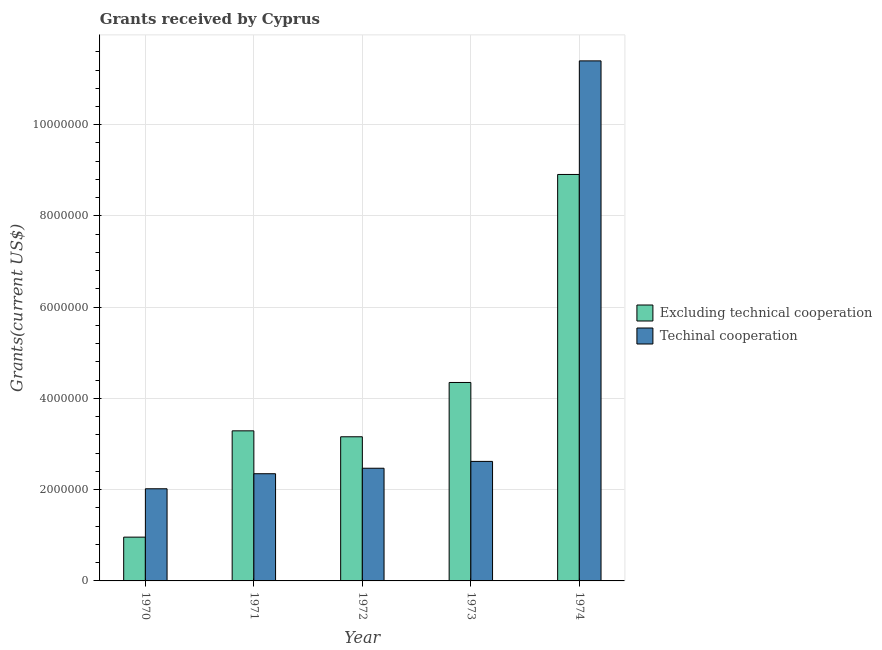How many groups of bars are there?
Your response must be concise. 5. Are the number of bars per tick equal to the number of legend labels?
Your answer should be compact. Yes. How many bars are there on the 2nd tick from the right?
Make the answer very short. 2. What is the amount of grants received(excluding technical cooperation) in 1971?
Give a very brief answer. 3.29e+06. Across all years, what is the maximum amount of grants received(excluding technical cooperation)?
Make the answer very short. 8.91e+06. Across all years, what is the minimum amount of grants received(including technical cooperation)?
Give a very brief answer. 2.02e+06. In which year was the amount of grants received(including technical cooperation) maximum?
Your response must be concise. 1974. What is the total amount of grants received(excluding technical cooperation) in the graph?
Provide a succinct answer. 2.07e+07. What is the difference between the amount of grants received(including technical cooperation) in 1971 and that in 1972?
Your answer should be very brief. -1.20e+05. What is the difference between the amount of grants received(including technical cooperation) in 1973 and the amount of grants received(excluding technical cooperation) in 1970?
Your answer should be compact. 6.00e+05. What is the average amount of grants received(including technical cooperation) per year?
Keep it short and to the point. 4.17e+06. What is the ratio of the amount of grants received(excluding technical cooperation) in 1973 to that in 1974?
Provide a succinct answer. 0.49. Is the amount of grants received(including technical cooperation) in 1970 less than that in 1973?
Provide a short and direct response. Yes. Is the difference between the amount of grants received(including technical cooperation) in 1970 and 1974 greater than the difference between the amount of grants received(excluding technical cooperation) in 1970 and 1974?
Provide a short and direct response. No. What is the difference between the highest and the second highest amount of grants received(including technical cooperation)?
Offer a terse response. 8.78e+06. What is the difference between the highest and the lowest amount of grants received(excluding technical cooperation)?
Keep it short and to the point. 7.95e+06. Is the sum of the amount of grants received(including technical cooperation) in 1972 and 1973 greater than the maximum amount of grants received(excluding technical cooperation) across all years?
Your answer should be very brief. No. What does the 1st bar from the left in 1973 represents?
Give a very brief answer. Excluding technical cooperation. What does the 2nd bar from the right in 1971 represents?
Your answer should be compact. Excluding technical cooperation. How many bars are there?
Provide a succinct answer. 10. How many years are there in the graph?
Make the answer very short. 5. What is the difference between two consecutive major ticks on the Y-axis?
Keep it short and to the point. 2.00e+06. Are the values on the major ticks of Y-axis written in scientific E-notation?
Give a very brief answer. No. Does the graph contain any zero values?
Make the answer very short. No. Does the graph contain grids?
Ensure brevity in your answer.  Yes. Where does the legend appear in the graph?
Keep it short and to the point. Center right. What is the title of the graph?
Offer a very short reply. Grants received by Cyprus. Does "Domestic Liabilities" appear as one of the legend labels in the graph?
Give a very brief answer. No. What is the label or title of the Y-axis?
Provide a succinct answer. Grants(current US$). What is the Grants(current US$) of Excluding technical cooperation in 1970?
Your answer should be compact. 9.60e+05. What is the Grants(current US$) in Techinal cooperation in 1970?
Provide a succinct answer. 2.02e+06. What is the Grants(current US$) of Excluding technical cooperation in 1971?
Offer a terse response. 3.29e+06. What is the Grants(current US$) in Techinal cooperation in 1971?
Your answer should be very brief. 2.35e+06. What is the Grants(current US$) of Excluding technical cooperation in 1972?
Provide a short and direct response. 3.16e+06. What is the Grants(current US$) in Techinal cooperation in 1972?
Keep it short and to the point. 2.47e+06. What is the Grants(current US$) of Excluding technical cooperation in 1973?
Your answer should be compact. 4.35e+06. What is the Grants(current US$) in Techinal cooperation in 1973?
Provide a succinct answer. 2.62e+06. What is the Grants(current US$) in Excluding technical cooperation in 1974?
Provide a succinct answer. 8.91e+06. What is the Grants(current US$) of Techinal cooperation in 1974?
Give a very brief answer. 1.14e+07. Across all years, what is the maximum Grants(current US$) of Excluding technical cooperation?
Ensure brevity in your answer.  8.91e+06. Across all years, what is the maximum Grants(current US$) of Techinal cooperation?
Make the answer very short. 1.14e+07. Across all years, what is the minimum Grants(current US$) in Excluding technical cooperation?
Offer a terse response. 9.60e+05. Across all years, what is the minimum Grants(current US$) of Techinal cooperation?
Provide a succinct answer. 2.02e+06. What is the total Grants(current US$) of Excluding technical cooperation in the graph?
Offer a very short reply. 2.07e+07. What is the total Grants(current US$) in Techinal cooperation in the graph?
Keep it short and to the point. 2.09e+07. What is the difference between the Grants(current US$) in Excluding technical cooperation in 1970 and that in 1971?
Give a very brief answer. -2.33e+06. What is the difference between the Grants(current US$) in Techinal cooperation in 1970 and that in 1971?
Offer a very short reply. -3.30e+05. What is the difference between the Grants(current US$) of Excluding technical cooperation in 1970 and that in 1972?
Offer a terse response. -2.20e+06. What is the difference between the Grants(current US$) of Techinal cooperation in 1970 and that in 1972?
Give a very brief answer. -4.50e+05. What is the difference between the Grants(current US$) in Excluding technical cooperation in 1970 and that in 1973?
Your answer should be very brief. -3.39e+06. What is the difference between the Grants(current US$) of Techinal cooperation in 1970 and that in 1973?
Make the answer very short. -6.00e+05. What is the difference between the Grants(current US$) of Excluding technical cooperation in 1970 and that in 1974?
Make the answer very short. -7.95e+06. What is the difference between the Grants(current US$) in Techinal cooperation in 1970 and that in 1974?
Provide a succinct answer. -9.38e+06. What is the difference between the Grants(current US$) of Techinal cooperation in 1971 and that in 1972?
Your answer should be very brief. -1.20e+05. What is the difference between the Grants(current US$) in Excluding technical cooperation in 1971 and that in 1973?
Your response must be concise. -1.06e+06. What is the difference between the Grants(current US$) in Excluding technical cooperation in 1971 and that in 1974?
Offer a very short reply. -5.62e+06. What is the difference between the Grants(current US$) in Techinal cooperation in 1971 and that in 1974?
Give a very brief answer. -9.05e+06. What is the difference between the Grants(current US$) in Excluding technical cooperation in 1972 and that in 1973?
Ensure brevity in your answer.  -1.19e+06. What is the difference between the Grants(current US$) of Excluding technical cooperation in 1972 and that in 1974?
Give a very brief answer. -5.75e+06. What is the difference between the Grants(current US$) in Techinal cooperation in 1972 and that in 1974?
Your answer should be compact. -8.93e+06. What is the difference between the Grants(current US$) of Excluding technical cooperation in 1973 and that in 1974?
Make the answer very short. -4.56e+06. What is the difference between the Grants(current US$) in Techinal cooperation in 1973 and that in 1974?
Your answer should be compact. -8.78e+06. What is the difference between the Grants(current US$) of Excluding technical cooperation in 1970 and the Grants(current US$) of Techinal cooperation in 1971?
Make the answer very short. -1.39e+06. What is the difference between the Grants(current US$) of Excluding technical cooperation in 1970 and the Grants(current US$) of Techinal cooperation in 1972?
Keep it short and to the point. -1.51e+06. What is the difference between the Grants(current US$) in Excluding technical cooperation in 1970 and the Grants(current US$) in Techinal cooperation in 1973?
Ensure brevity in your answer.  -1.66e+06. What is the difference between the Grants(current US$) in Excluding technical cooperation in 1970 and the Grants(current US$) in Techinal cooperation in 1974?
Offer a very short reply. -1.04e+07. What is the difference between the Grants(current US$) of Excluding technical cooperation in 1971 and the Grants(current US$) of Techinal cooperation in 1972?
Your answer should be very brief. 8.20e+05. What is the difference between the Grants(current US$) in Excluding technical cooperation in 1971 and the Grants(current US$) in Techinal cooperation in 1973?
Your answer should be very brief. 6.70e+05. What is the difference between the Grants(current US$) in Excluding technical cooperation in 1971 and the Grants(current US$) in Techinal cooperation in 1974?
Make the answer very short. -8.11e+06. What is the difference between the Grants(current US$) in Excluding technical cooperation in 1972 and the Grants(current US$) in Techinal cooperation in 1973?
Provide a short and direct response. 5.40e+05. What is the difference between the Grants(current US$) in Excluding technical cooperation in 1972 and the Grants(current US$) in Techinal cooperation in 1974?
Keep it short and to the point. -8.24e+06. What is the difference between the Grants(current US$) of Excluding technical cooperation in 1973 and the Grants(current US$) of Techinal cooperation in 1974?
Provide a short and direct response. -7.05e+06. What is the average Grants(current US$) in Excluding technical cooperation per year?
Your answer should be compact. 4.13e+06. What is the average Grants(current US$) in Techinal cooperation per year?
Your response must be concise. 4.17e+06. In the year 1970, what is the difference between the Grants(current US$) of Excluding technical cooperation and Grants(current US$) of Techinal cooperation?
Offer a very short reply. -1.06e+06. In the year 1971, what is the difference between the Grants(current US$) in Excluding technical cooperation and Grants(current US$) in Techinal cooperation?
Offer a terse response. 9.40e+05. In the year 1972, what is the difference between the Grants(current US$) in Excluding technical cooperation and Grants(current US$) in Techinal cooperation?
Your response must be concise. 6.90e+05. In the year 1973, what is the difference between the Grants(current US$) in Excluding technical cooperation and Grants(current US$) in Techinal cooperation?
Your answer should be compact. 1.73e+06. In the year 1974, what is the difference between the Grants(current US$) in Excluding technical cooperation and Grants(current US$) in Techinal cooperation?
Your response must be concise. -2.49e+06. What is the ratio of the Grants(current US$) in Excluding technical cooperation in 1970 to that in 1971?
Provide a short and direct response. 0.29. What is the ratio of the Grants(current US$) of Techinal cooperation in 1970 to that in 1971?
Keep it short and to the point. 0.86. What is the ratio of the Grants(current US$) in Excluding technical cooperation in 1970 to that in 1972?
Provide a short and direct response. 0.3. What is the ratio of the Grants(current US$) in Techinal cooperation in 1970 to that in 1972?
Your response must be concise. 0.82. What is the ratio of the Grants(current US$) in Excluding technical cooperation in 1970 to that in 1973?
Your answer should be compact. 0.22. What is the ratio of the Grants(current US$) of Techinal cooperation in 1970 to that in 1973?
Your response must be concise. 0.77. What is the ratio of the Grants(current US$) of Excluding technical cooperation in 1970 to that in 1974?
Offer a very short reply. 0.11. What is the ratio of the Grants(current US$) in Techinal cooperation in 1970 to that in 1974?
Offer a very short reply. 0.18. What is the ratio of the Grants(current US$) of Excluding technical cooperation in 1971 to that in 1972?
Your response must be concise. 1.04. What is the ratio of the Grants(current US$) in Techinal cooperation in 1971 to that in 1972?
Your response must be concise. 0.95. What is the ratio of the Grants(current US$) in Excluding technical cooperation in 1971 to that in 1973?
Your answer should be compact. 0.76. What is the ratio of the Grants(current US$) in Techinal cooperation in 1971 to that in 1973?
Keep it short and to the point. 0.9. What is the ratio of the Grants(current US$) in Excluding technical cooperation in 1971 to that in 1974?
Give a very brief answer. 0.37. What is the ratio of the Grants(current US$) in Techinal cooperation in 1971 to that in 1974?
Offer a terse response. 0.21. What is the ratio of the Grants(current US$) in Excluding technical cooperation in 1972 to that in 1973?
Offer a terse response. 0.73. What is the ratio of the Grants(current US$) in Techinal cooperation in 1972 to that in 1973?
Make the answer very short. 0.94. What is the ratio of the Grants(current US$) of Excluding technical cooperation in 1972 to that in 1974?
Your response must be concise. 0.35. What is the ratio of the Grants(current US$) in Techinal cooperation in 1972 to that in 1974?
Keep it short and to the point. 0.22. What is the ratio of the Grants(current US$) of Excluding technical cooperation in 1973 to that in 1974?
Give a very brief answer. 0.49. What is the ratio of the Grants(current US$) in Techinal cooperation in 1973 to that in 1974?
Provide a short and direct response. 0.23. What is the difference between the highest and the second highest Grants(current US$) in Excluding technical cooperation?
Offer a very short reply. 4.56e+06. What is the difference between the highest and the second highest Grants(current US$) in Techinal cooperation?
Your response must be concise. 8.78e+06. What is the difference between the highest and the lowest Grants(current US$) of Excluding technical cooperation?
Provide a succinct answer. 7.95e+06. What is the difference between the highest and the lowest Grants(current US$) of Techinal cooperation?
Ensure brevity in your answer.  9.38e+06. 